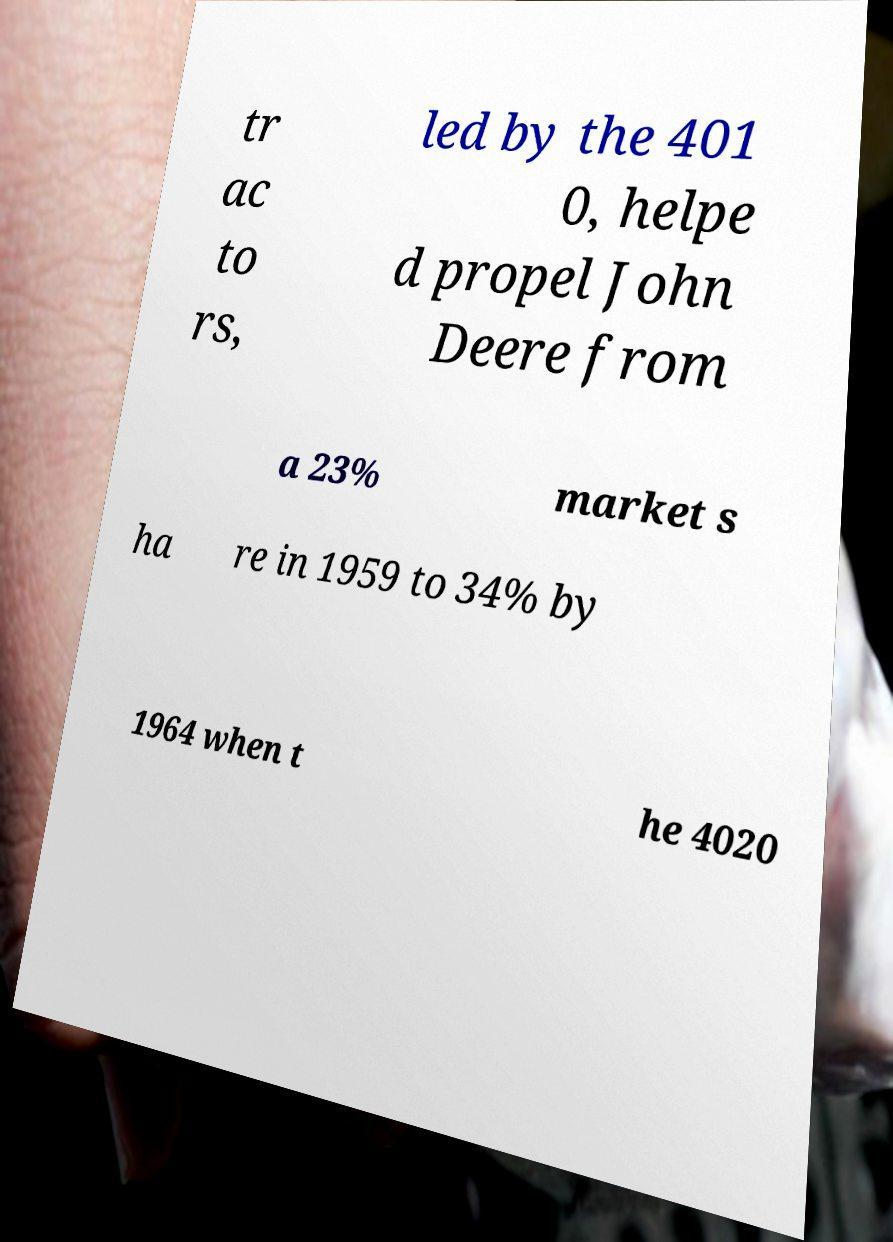Please read and relay the text visible in this image. What does it say? tr ac to rs, led by the 401 0, helpe d propel John Deere from a 23% market s ha re in 1959 to 34% by 1964 when t he 4020 